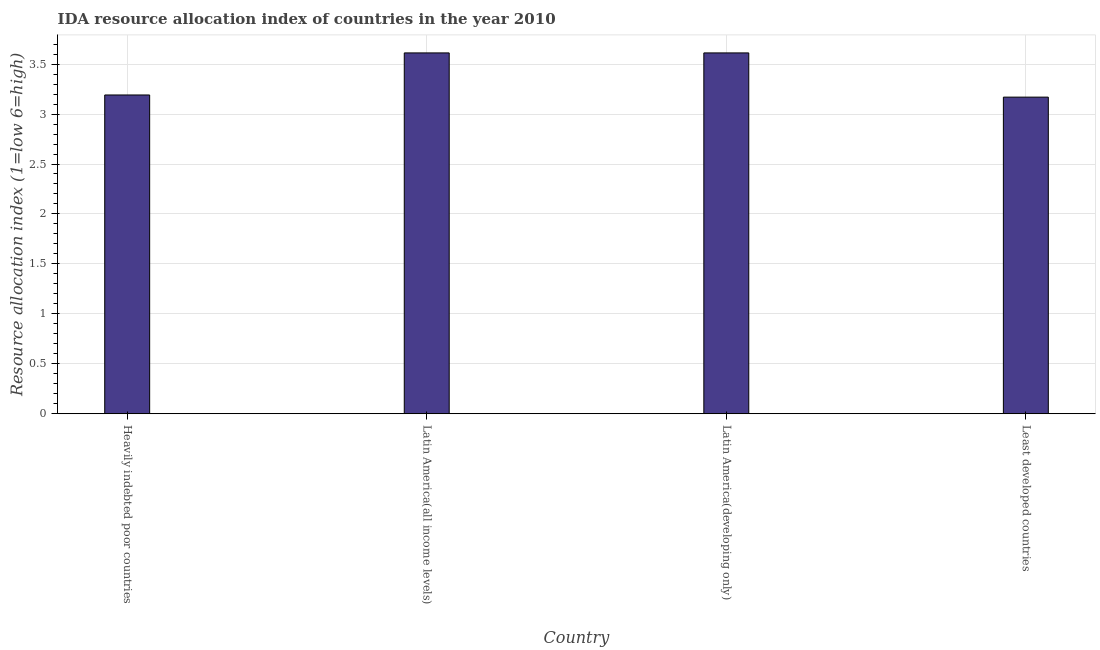Does the graph contain any zero values?
Provide a succinct answer. No. What is the title of the graph?
Make the answer very short. IDA resource allocation index of countries in the year 2010. What is the label or title of the X-axis?
Provide a succinct answer. Country. What is the label or title of the Y-axis?
Give a very brief answer. Resource allocation index (1=low 6=high). What is the ida resource allocation index in Heavily indebted poor countries?
Offer a terse response. 3.19. Across all countries, what is the maximum ida resource allocation index?
Make the answer very short. 3.61. Across all countries, what is the minimum ida resource allocation index?
Offer a terse response. 3.17. In which country was the ida resource allocation index maximum?
Keep it short and to the point. Latin America(all income levels). In which country was the ida resource allocation index minimum?
Provide a succinct answer. Least developed countries. What is the sum of the ida resource allocation index?
Keep it short and to the point. 13.58. What is the difference between the ida resource allocation index in Latin America(developing only) and Least developed countries?
Ensure brevity in your answer.  0.44. What is the average ida resource allocation index per country?
Keep it short and to the point. 3.4. What is the median ida resource allocation index?
Offer a very short reply. 3.4. What is the ratio of the ida resource allocation index in Latin America(developing only) to that in Least developed countries?
Offer a very short reply. 1.14. Is the ida resource allocation index in Heavily indebted poor countries less than that in Least developed countries?
Keep it short and to the point. No. Is the difference between the ida resource allocation index in Latin America(developing only) and Least developed countries greater than the difference between any two countries?
Offer a terse response. Yes. What is the difference between the highest and the second highest ida resource allocation index?
Offer a terse response. 0. Is the sum of the ida resource allocation index in Latin America(developing only) and Least developed countries greater than the maximum ida resource allocation index across all countries?
Your answer should be compact. Yes. What is the difference between the highest and the lowest ida resource allocation index?
Your answer should be compact. 0.44. Are all the bars in the graph horizontal?
Provide a short and direct response. No. How many countries are there in the graph?
Your answer should be very brief. 4. What is the difference between two consecutive major ticks on the Y-axis?
Ensure brevity in your answer.  0.5. Are the values on the major ticks of Y-axis written in scientific E-notation?
Make the answer very short. No. What is the Resource allocation index (1=low 6=high) of Heavily indebted poor countries?
Keep it short and to the point. 3.19. What is the Resource allocation index (1=low 6=high) of Latin America(all income levels)?
Your response must be concise. 3.61. What is the Resource allocation index (1=low 6=high) in Latin America(developing only)?
Offer a very short reply. 3.61. What is the Resource allocation index (1=low 6=high) in Least developed countries?
Provide a short and direct response. 3.17. What is the difference between the Resource allocation index (1=low 6=high) in Heavily indebted poor countries and Latin America(all income levels)?
Your answer should be very brief. -0.42. What is the difference between the Resource allocation index (1=low 6=high) in Heavily indebted poor countries and Latin America(developing only)?
Ensure brevity in your answer.  -0.42. What is the difference between the Resource allocation index (1=low 6=high) in Heavily indebted poor countries and Least developed countries?
Your answer should be very brief. 0.02. What is the difference between the Resource allocation index (1=low 6=high) in Latin America(all income levels) and Least developed countries?
Offer a terse response. 0.44. What is the difference between the Resource allocation index (1=low 6=high) in Latin America(developing only) and Least developed countries?
Keep it short and to the point. 0.44. What is the ratio of the Resource allocation index (1=low 6=high) in Heavily indebted poor countries to that in Latin America(all income levels)?
Offer a very short reply. 0.88. What is the ratio of the Resource allocation index (1=low 6=high) in Heavily indebted poor countries to that in Latin America(developing only)?
Offer a terse response. 0.88. What is the ratio of the Resource allocation index (1=low 6=high) in Heavily indebted poor countries to that in Least developed countries?
Make the answer very short. 1.01. What is the ratio of the Resource allocation index (1=low 6=high) in Latin America(all income levels) to that in Least developed countries?
Offer a very short reply. 1.14. What is the ratio of the Resource allocation index (1=low 6=high) in Latin America(developing only) to that in Least developed countries?
Keep it short and to the point. 1.14. 